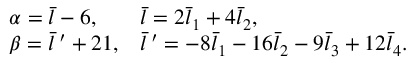Convert formula to latex. <formula><loc_0><loc_0><loc_500><loc_500>\begin{array} { l l } { { \alpha = \bar { l } - 6 , } } & { { \bar { l } = 2 \bar { l } _ { 1 } + 4 \bar { l } _ { 2 } , } } \\ { { \beta = \bar { l } \, ^ { \prime } + 2 1 , } } & { { \bar { l } \, ^ { \prime } = - 8 \bar { l } _ { 1 } - 1 6 \bar { l } _ { 2 } - 9 \bar { l } _ { 3 } + 1 2 \bar { l } _ { 4 } . } } \end{array}</formula> 